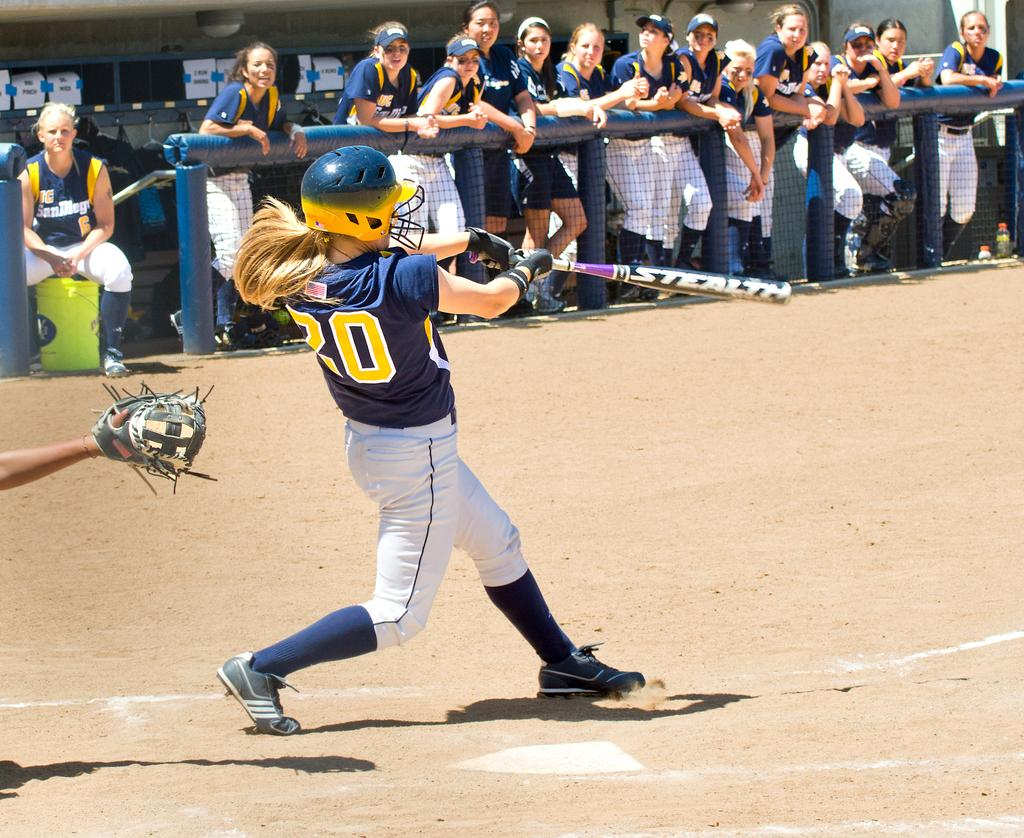What is the person in the image holding? The person in the image is holding a bat. What can be seen in the background of the image? There is a group of people, a mesh, and posters in the background of the image. What type of cheese is being used to sew the needle in the image? There is no cheese, needle, or sewing activity present in the image. 